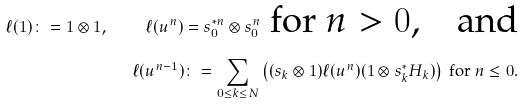Convert formula to latex. <formula><loc_0><loc_0><loc_500><loc_500>\ell ( 1 ) \colon = 1 \otimes 1 , \quad \ell ( u ^ { n } ) = s ^ { * n } _ { 0 } \otimes s ^ { n } _ { 0 } \text { for $n > 0$,\quad and} \\ \ell ( u ^ { n - 1 } ) \colon = \sum _ { 0 \leq k \leq N } \left ( ( s _ { k } \otimes 1 ) \ell ( u ^ { n } ) ( 1 \otimes s ^ { * } _ { k } H _ { k } ) \right ) \text { for $n \leq 0$.}</formula> 